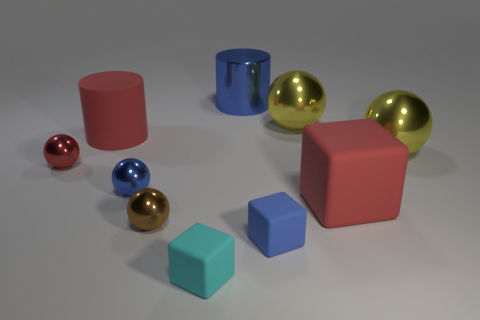What is the color of the shiny thing that is behind the big ball that is behind the matte thing behind the small red shiny thing?
Keep it short and to the point. Blue. Is the number of big blue shiny cylinders less than the number of big brown spheres?
Your answer should be very brief. No. The other large matte object that is the same shape as the blue rubber thing is what color?
Keep it short and to the point. Red. What color is the large cylinder that is the same material as the small red ball?
Make the answer very short. Blue. What number of red metallic things are the same size as the rubber cylinder?
Your answer should be compact. 0. What is the tiny blue cube made of?
Make the answer very short. Rubber. Is the number of big blue cylinders greater than the number of big blue metal spheres?
Give a very brief answer. Yes. Do the tiny cyan object and the tiny blue matte thing have the same shape?
Provide a short and direct response. Yes. Is the color of the large cylinder that is in front of the big blue object the same as the big thing that is in front of the tiny red metallic object?
Your answer should be compact. Yes. Are there fewer tiny blue shiny things that are behind the red cylinder than red rubber things that are left of the tiny blue shiny thing?
Provide a succinct answer. Yes. 